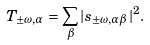Convert formula to latex. <formula><loc_0><loc_0><loc_500><loc_500>T _ { \pm \omega , \alpha } = \sum _ { \beta } | s _ { \pm \omega , \alpha \beta } | ^ { 2 } .</formula> 